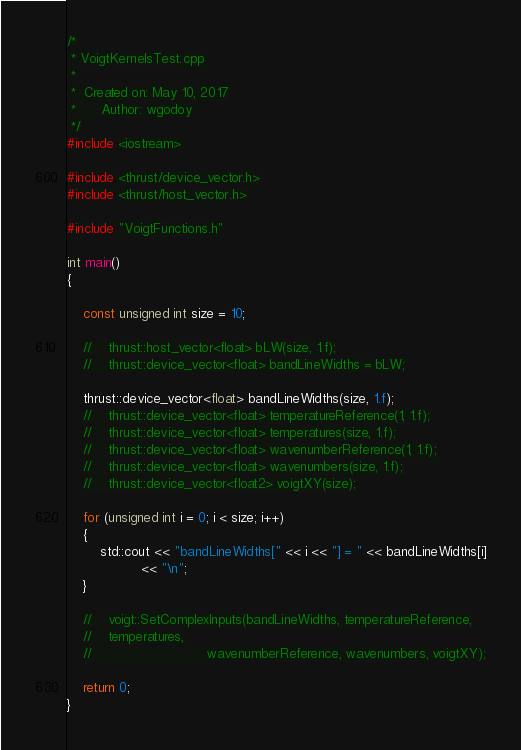<code> <loc_0><loc_0><loc_500><loc_500><_Cuda_>/*
 * VoigtKernelsTest.cpp
 *
 *  Created on: May 10, 2017
 *      Author: wgodoy
 */
#include <iostream>

#include <thrust/device_vector.h>
#include <thrust/host_vector.h>

#include "VoigtFunctions.h"

int main()
{

    const unsigned int size = 10;

    //    thrust::host_vector<float> bLW(size, 1.f);
    //    thrust::device_vector<float> bandLineWidths = bLW;

    thrust::device_vector<float> bandLineWidths(size, 1.f);
    //    thrust::device_vector<float> temperatureReference(1, 1.f);
    //    thrust::device_vector<float> temperatures(size, 1.f);
    //    thrust::device_vector<float> wavenumberReference(1, 1.f);
    //    thrust::device_vector<float> wavenumbers(size, 1.f);
    //    thrust::device_vector<float2> voigtXY(size);

    for (unsigned int i = 0; i < size; i++)
    {
        std::cout << "bandLineWidths[" << i << "] = " << bandLineWidths[i]
                  << "\n";
    }

    //    voigt::SetComplexInputs(bandLineWidths, temperatureReference,
    //    temperatures,
    //                            wavenumberReference, wavenumbers, voigtXY);

    return 0;
}
</code> 